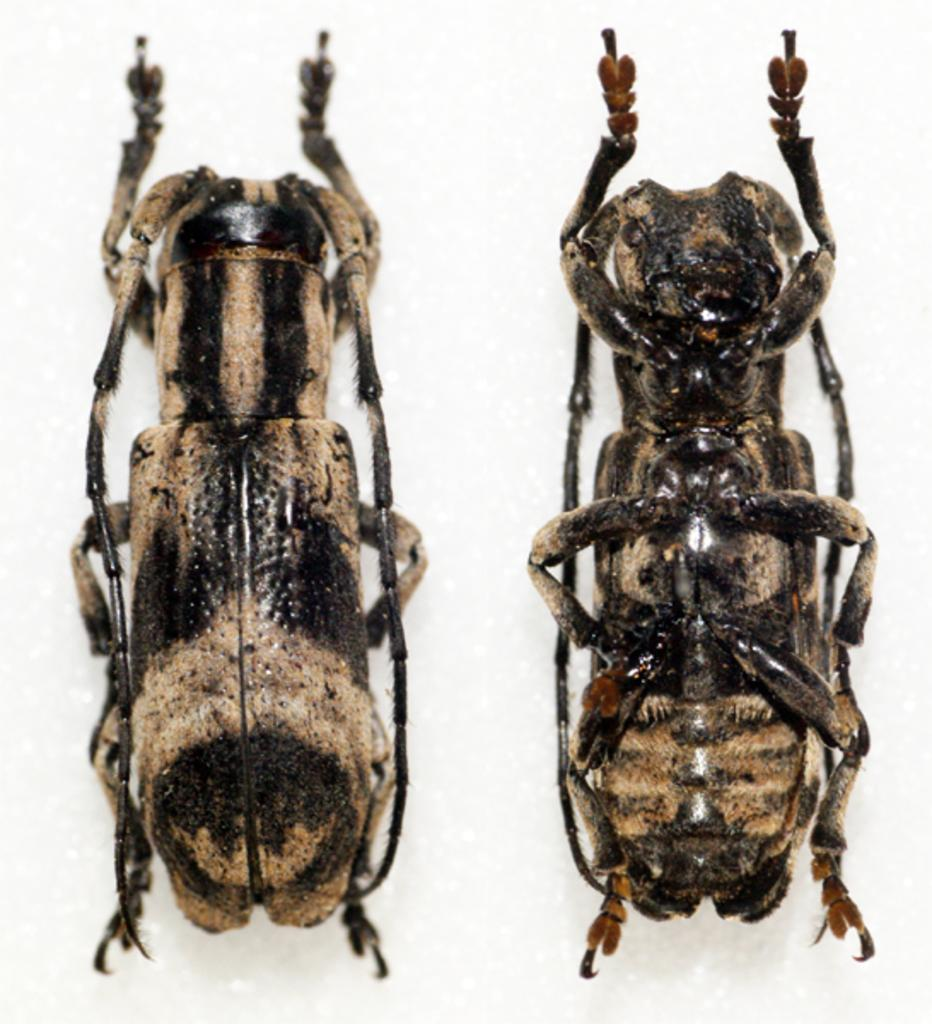What type of living organism can be seen in the image? The image contains an insect. Can you describe the insect's structure? The insect has inner and outer layers. What color is the background of the image? The background of the image is white. How does the wind affect the calculator in the image? There is no calculator present in the image, so the wind's effect cannot be determined. What type of bead can be seen in the image? There is no bead present in the image. 